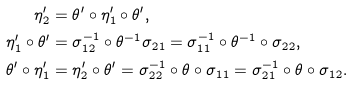Convert formula to latex. <formula><loc_0><loc_0><loc_500><loc_500>\eta ^ { \prime } _ { 2 } & = \theta ^ { \prime } \circ \eta ^ { \prime } _ { 1 } \circ \theta ^ { \prime } , \\ \eta ^ { \prime } _ { 1 } \circ \theta ^ { \prime } & = \sigma _ { 1 2 } ^ { - 1 } \circ \theta ^ { - 1 } \sigma _ { 2 1 } = \sigma _ { 1 1 } ^ { - 1 } \circ \theta ^ { - 1 } \circ \sigma _ { 2 2 } , \\ \theta ^ { \prime } \circ \eta ^ { \prime } _ { 1 } & = \eta ^ { \prime } _ { 2 } \circ \theta ^ { \prime } = \sigma _ { 2 2 } ^ { - 1 } \circ \theta \circ \sigma _ { 1 1 } = \sigma _ { 2 1 } ^ { - 1 } \circ \theta \circ \sigma _ { 1 2 } .</formula> 